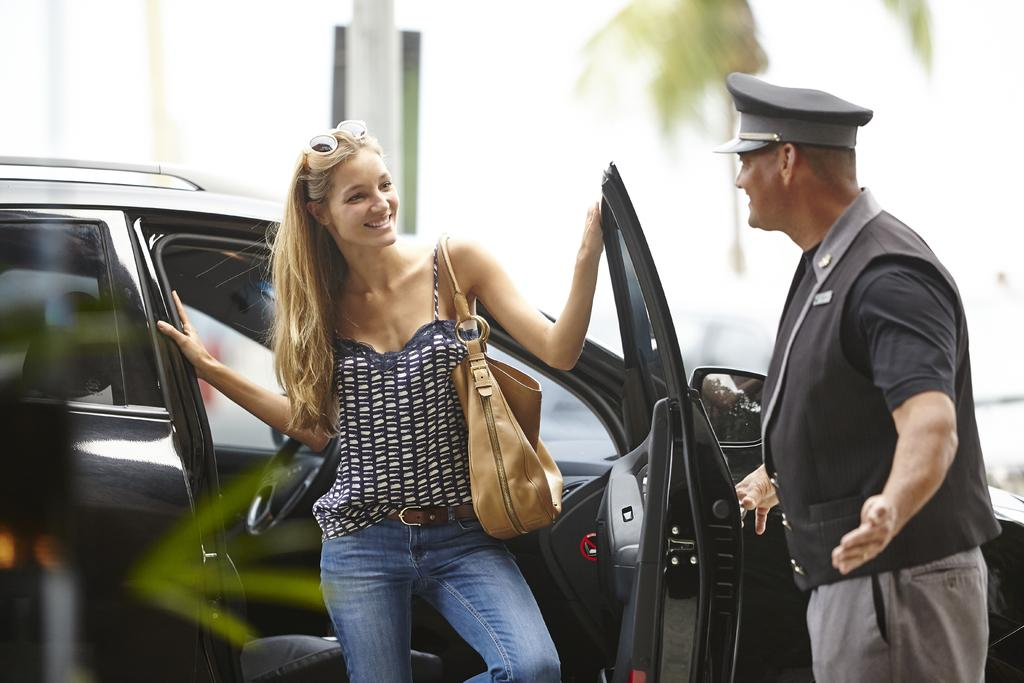What is the woman doing in the image? The woman is standing near a car in the image. Who is with the woman in the image? There is a man standing beside the woman in the image. What can be seen behind the woman in the image? There is a tree behind the woman in the image. How would you describe the weather based on the image? The sky is clear in the image, suggesting good weather. What type of string is the boy playing with in the image? There is no boy present in the image, so there is no string or any related activity. 